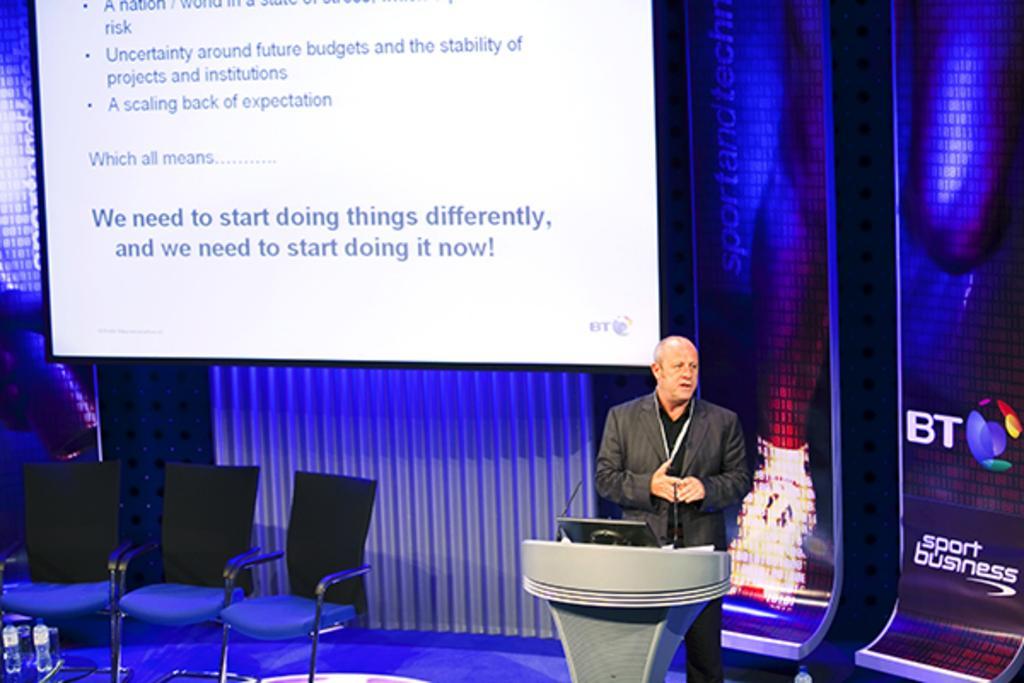In one or two sentences, can you explain what this image depicts? This picture describe about the man wearing black coat is standing at the speech desk and delivering the speech having a laptop on the table. Beside we can see the black chair and in front a table on which water bottles are kept. Behind we can see the projector screen and banner on which BT sports business is written. 